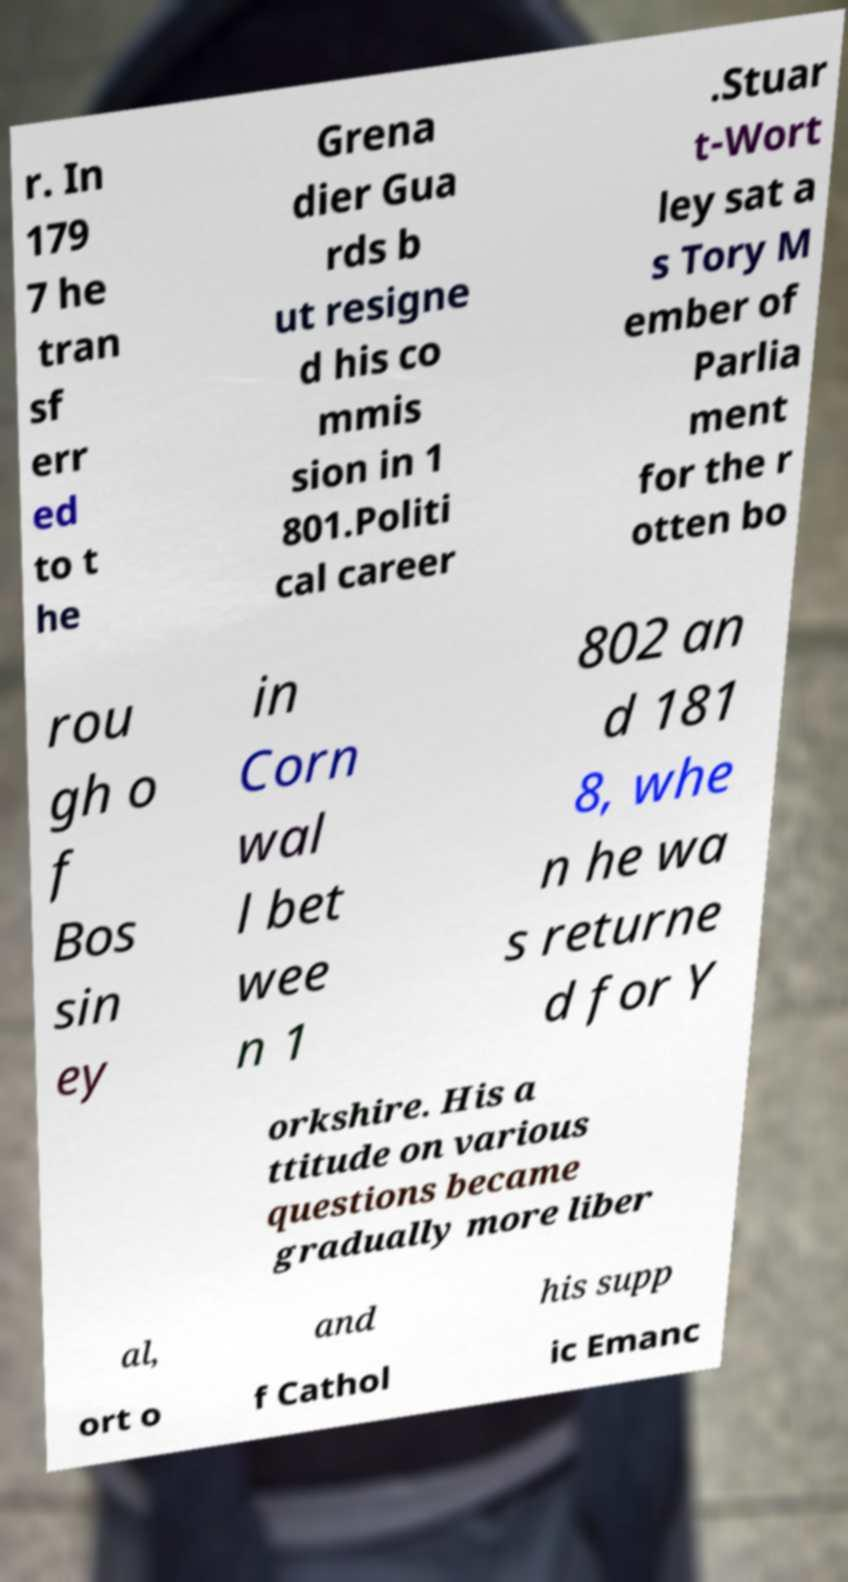For documentation purposes, I need the text within this image transcribed. Could you provide that? r. In 179 7 he tran sf err ed to t he Grena dier Gua rds b ut resigne d his co mmis sion in 1 801.Politi cal career .Stuar t-Wort ley sat a s Tory M ember of Parlia ment for the r otten bo rou gh o f Bos sin ey in Corn wal l bet wee n 1 802 an d 181 8, whe n he wa s returne d for Y orkshire. His a ttitude on various questions became gradually more liber al, and his supp ort o f Cathol ic Emanc 